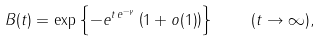Convert formula to latex. <formula><loc_0><loc_0><loc_500><loc_500>B ( t ) = \exp \left \{ - e ^ { t \, e ^ { - \gamma } } \left ( 1 + o ( 1 ) \right ) \right \} \quad ( t \rightarrow \infty ) ,</formula> 